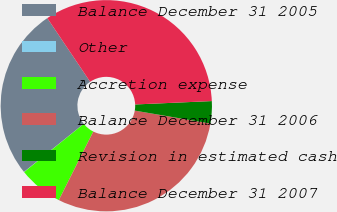<chart> <loc_0><loc_0><loc_500><loc_500><pie_chart><fcel>Balance December 31 2005<fcel>Other<fcel>Accretion expense<fcel>Balance December 31 2006<fcel>Revision in estimated cash<fcel>Balance December 31 2007<nl><fcel>26.35%<fcel>0.03%<fcel>6.77%<fcel>29.72%<fcel>3.4%<fcel>33.73%<nl></chart> 